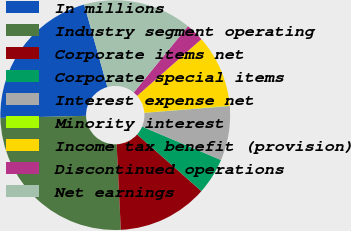Convert chart. <chart><loc_0><loc_0><loc_500><loc_500><pie_chart><fcel>In millions<fcel>Industry segment operating<fcel>Corporate items net<fcel>Corporate special items<fcel>Interest expense net<fcel>Minority interest<fcel>Income tax benefit (provision)<fcel>Discontinued operations<fcel>Net earnings<nl><fcel>21.03%<fcel>25.39%<fcel>12.72%<fcel>5.12%<fcel>7.65%<fcel>0.05%<fcel>10.19%<fcel>2.59%<fcel>15.26%<nl></chart> 